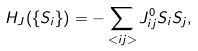Convert formula to latex. <formula><loc_0><loc_0><loc_500><loc_500>H _ { J } ( \{ S _ { i } \} ) = - \sum _ { < i j > } J _ { i j } ^ { 0 } S _ { i } S _ { j } ,</formula> 